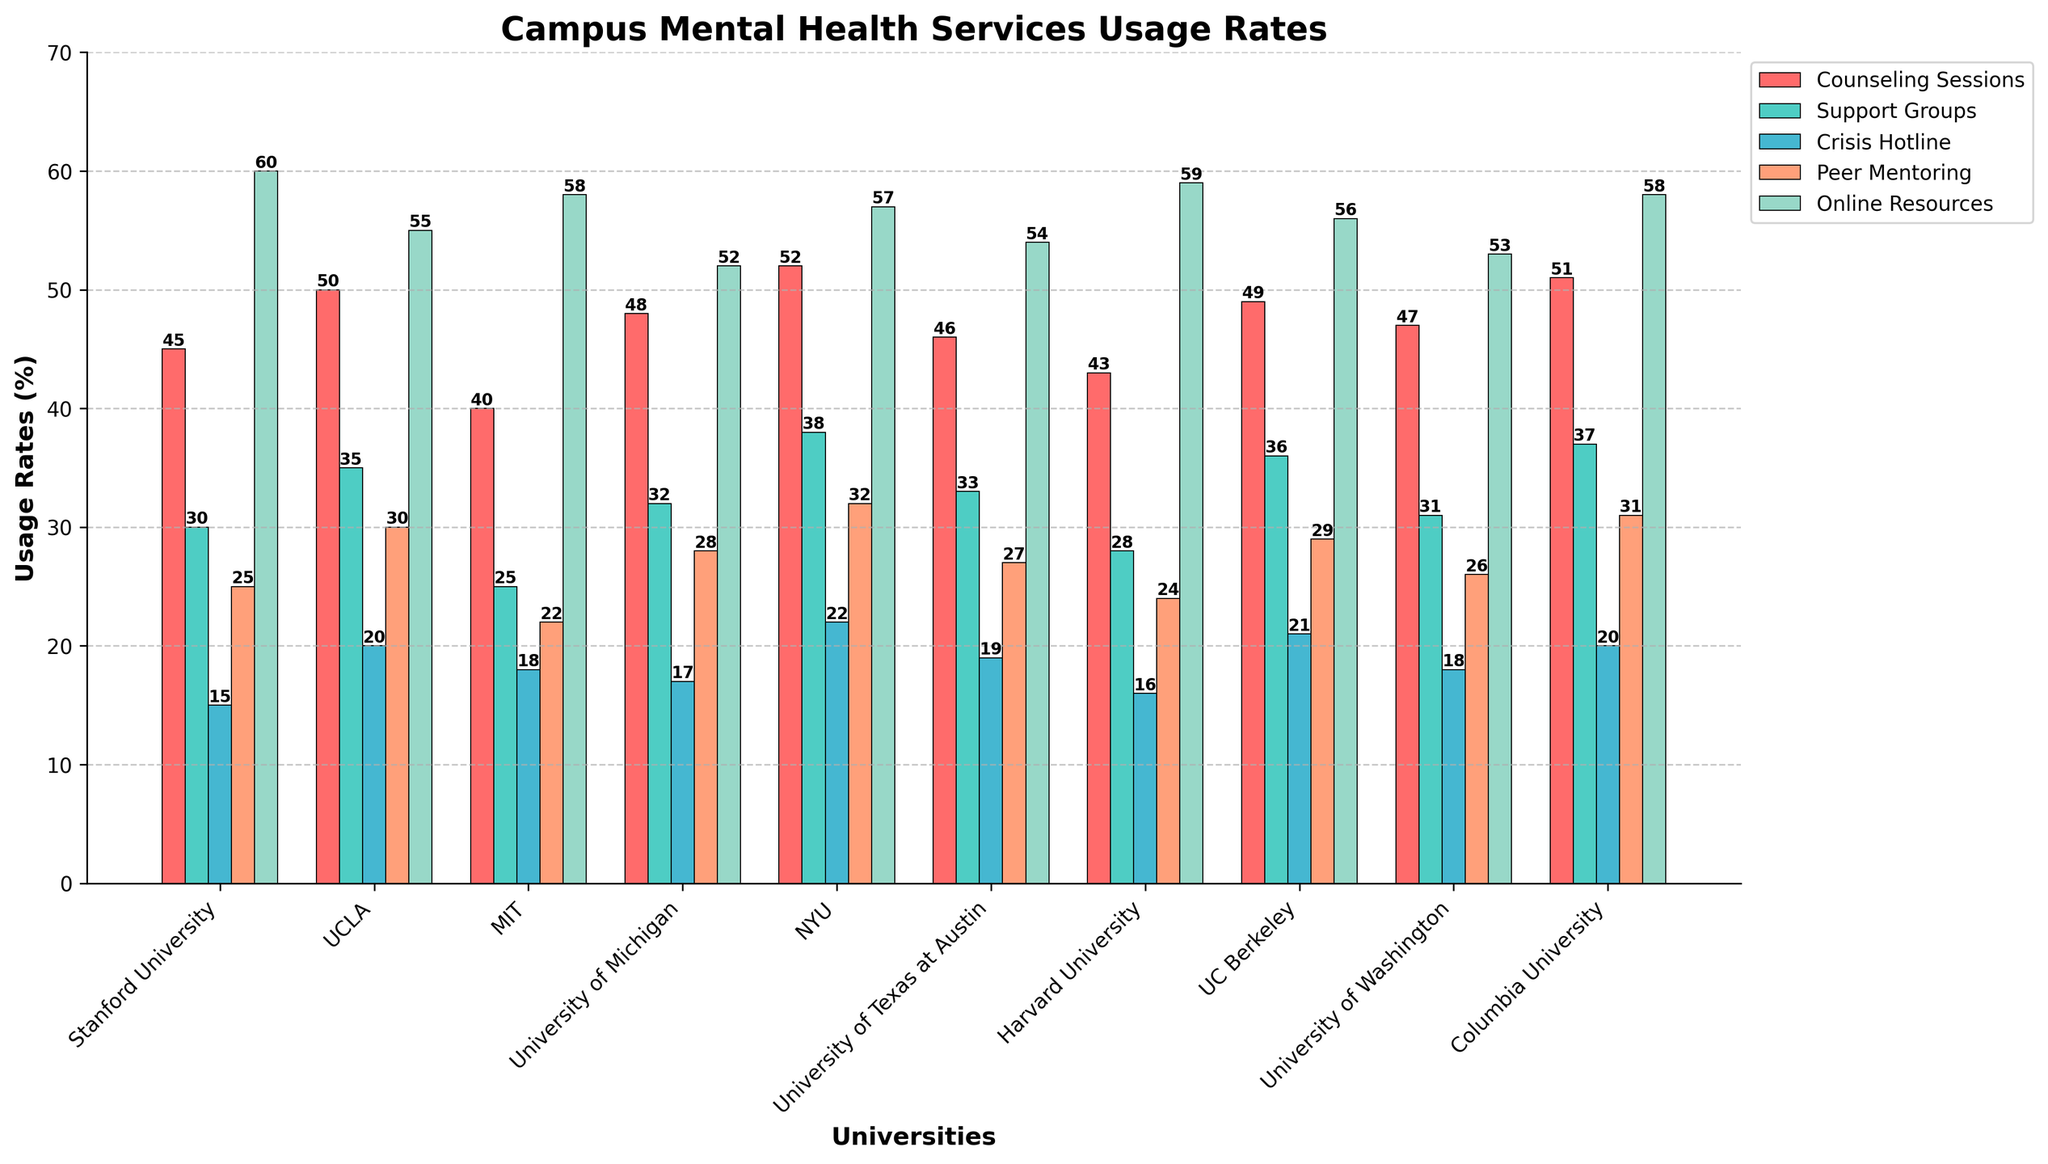What type of mental health service has the highest usage rate at Stanford University? By observing the bars that represent Stanford University, we see that the "Online Resources" category, which is visually the tallest bar, has the highest usage rate.
Answer: Online Resources Which university has the highest usage rate for Support Groups? By comparing the lengths of the bars representing "Support Groups" across all universities, we see that NYU has the tallest bar in this category.
Answer: NYU What is the difference in the usage rate of Counseling Sessions between Harvard University and Columbia University? The bar for Counseling Sessions at Columbia University is at 51, while at Harvard University it is at 43. The difference is 51 - 43.
Answer: 8 Which university has the lowest usage rate for Peer Mentoring? By looking at the height of the bars representing Peer Mentoring across all universities, MIT has the shortest bar, which corresponds to the lowest usage rate.
Answer: MIT How many more students use Online Resources compared to Crisis Hotline at UCLA? The usage rates for Online Resources and Crisis Hotline at UCLA are 55 and 20 respectively. The difference is 55 - 20.
Answer: 35 What is the combined usage rate of Crisis Hotline and Support Groups at UC Berkeley? The usage rates for Crisis Hotline and Support Groups at UC Berkeley are 21 and 36 respectively. Their combined usage rate is 21 + 36.
Answer: 57 Which category has the smallest range of usage rates across all universities? First, we calculate the ranges for each category: Counseling Sessions (52 - 40), Support Groups (38 - 25), Crisis Hotline (22 - 15), Peer Mentoring (32 - 22), Online Resources (60 - 52). Crisis Hotline has the smallest range of 7.
Answer: Crisis Hotline Which university has the highest total usage rate across all types of services? To find this, we sum the usage rates for each university: Stanford (175), UCLA (190), MIT (163), University of Michigan (177), NYU (201), University of Texas at Austin (179), Harvard (170), UC Berkeley (191), University of Washington (175), Columbia (197). NYU has the highest total with 201.
Answer: NYU What is the average usage rate for Online Resources across all universities? First, sum the usage rates for Online Resources across all universities: 60 + 55 + 58 + 52 + 57 + 54 + 59 + 56 + 53 + 58 = 562. Then, divide by the number of universities (10). The average is 562 / 10.
Answer: 56.2 